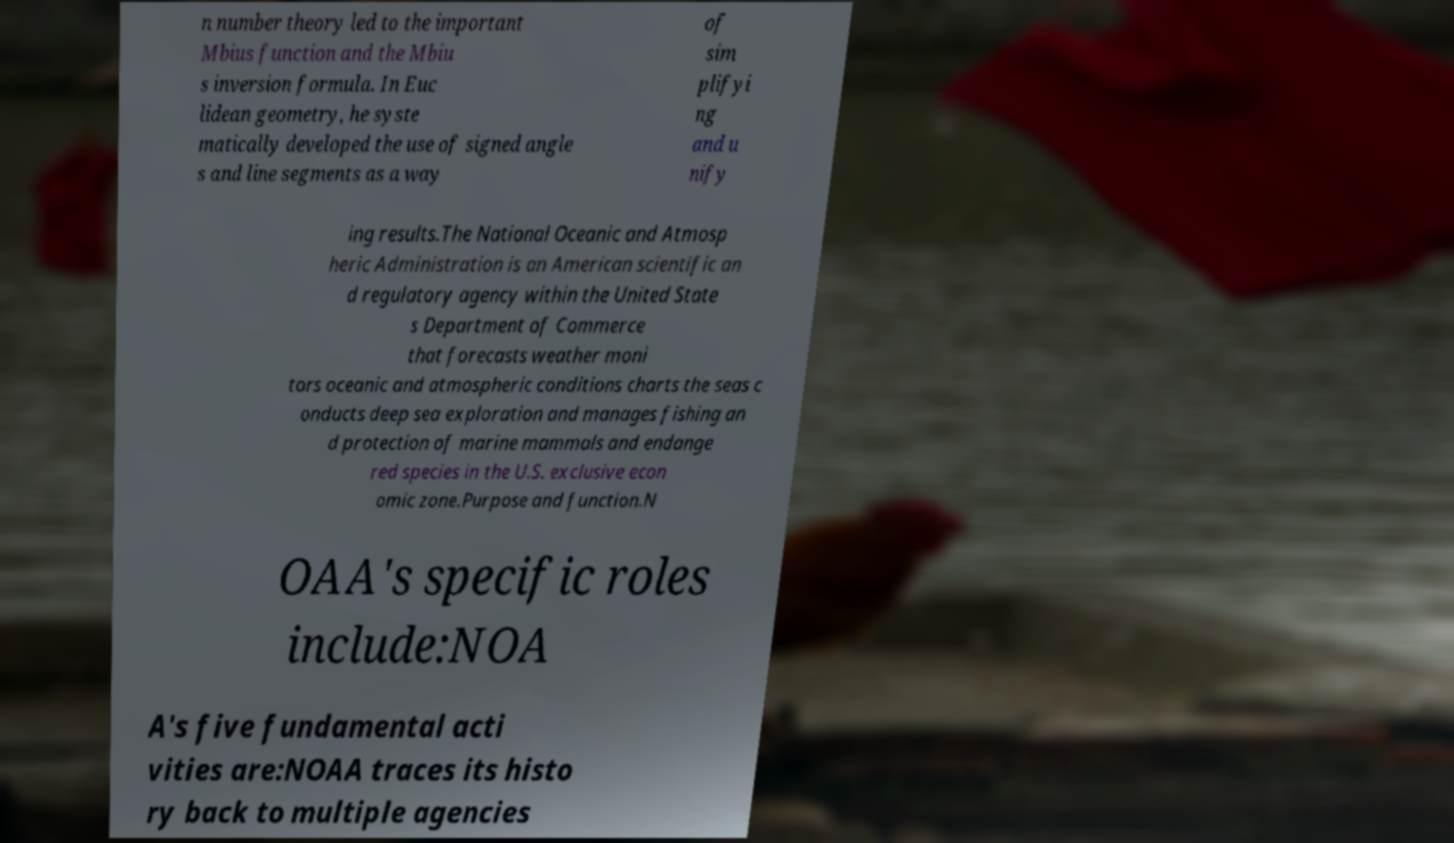For documentation purposes, I need the text within this image transcribed. Could you provide that? n number theory led to the important Mbius function and the Mbiu s inversion formula. In Euc lidean geometry, he syste matically developed the use of signed angle s and line segments as a way of sim plifyi ng and u nify ing results.The National Oceanic and Atmosp heric Administration is an American scientific an d regulatory agency within the United State s Department of Commerce that forecasts weather moni tors oceanic and atmospheric conditions charts the seas c onducts deep sea exploration and manages fishing an d protection of marine mammals and endange red species in the U.S. exclusive econ omic zone.Purpose and function.N OAA's specific roles include:NOA A's five fundamental acti vities are:NOAA traces its histo ry back to multiple agencies 